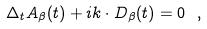<formula> <loc_0><loc_0><loc_500><loc_500>\Delta _ { t } A _ { \beta } ( t ) + i k \cdot { D } _ { \beta } ( t ) = 0 \ ,</formula> 